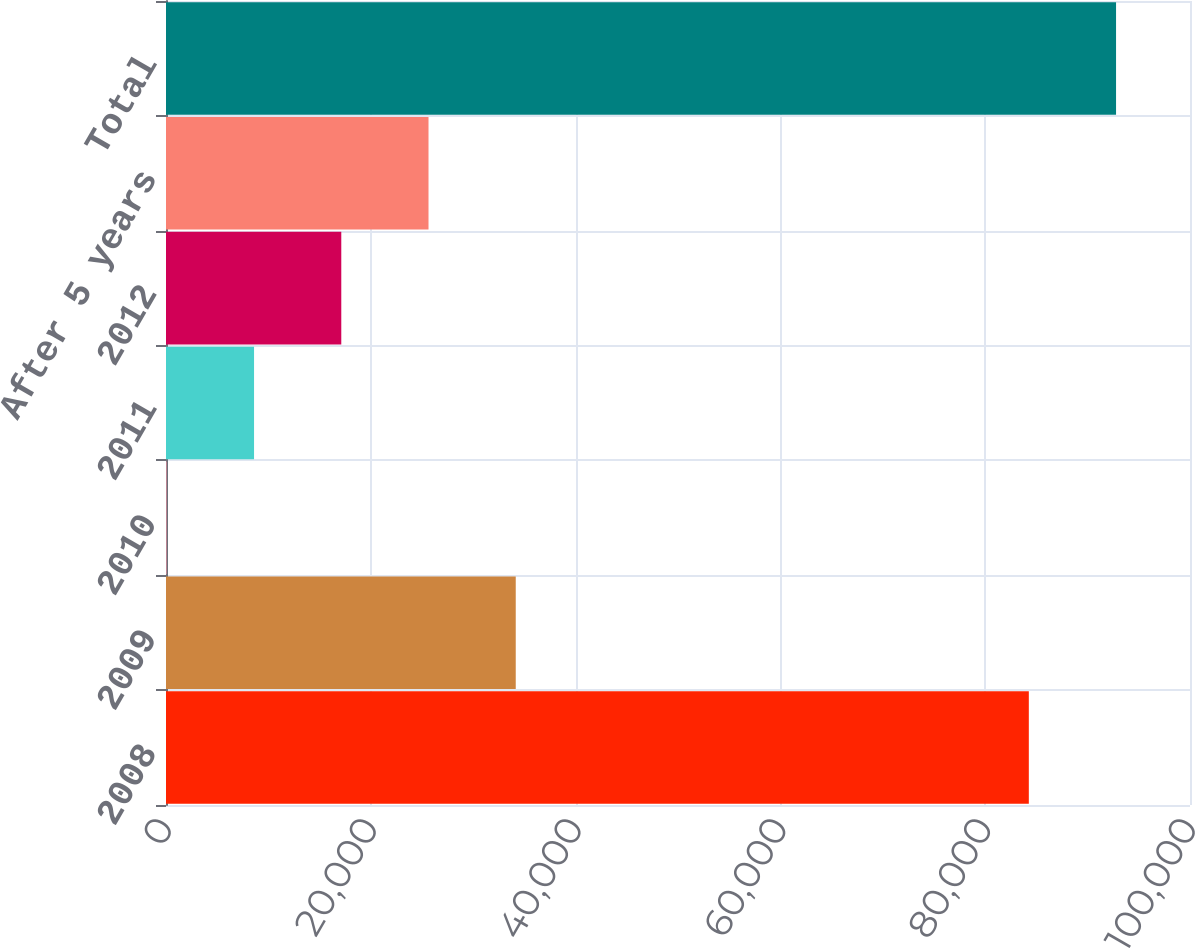<chart> <loc_0><loc_0><loc_500><loc_500><bar_chart><fcel>2008<fcel>2009<fcel>2010<fcel>2011<fcel>2012<fcel>After 5 years<fcel>Total<nl><fcel>84260<fcel>34154.8<fcel>80<fcel>8598.7<fcel>17117.4<fcel>25636.1<fcel>92778.7<nl></chart> 